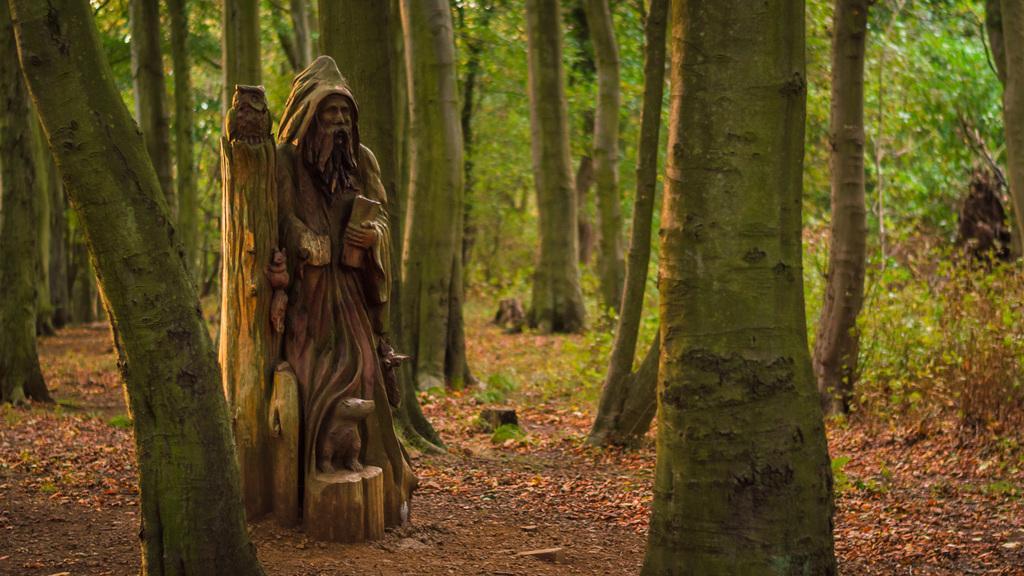How would you summarize this image in a sentence or two? In this image we can see a statue of a person holding something. Near to him there are statues of few animals and a bird. Also there are trees in this image. 